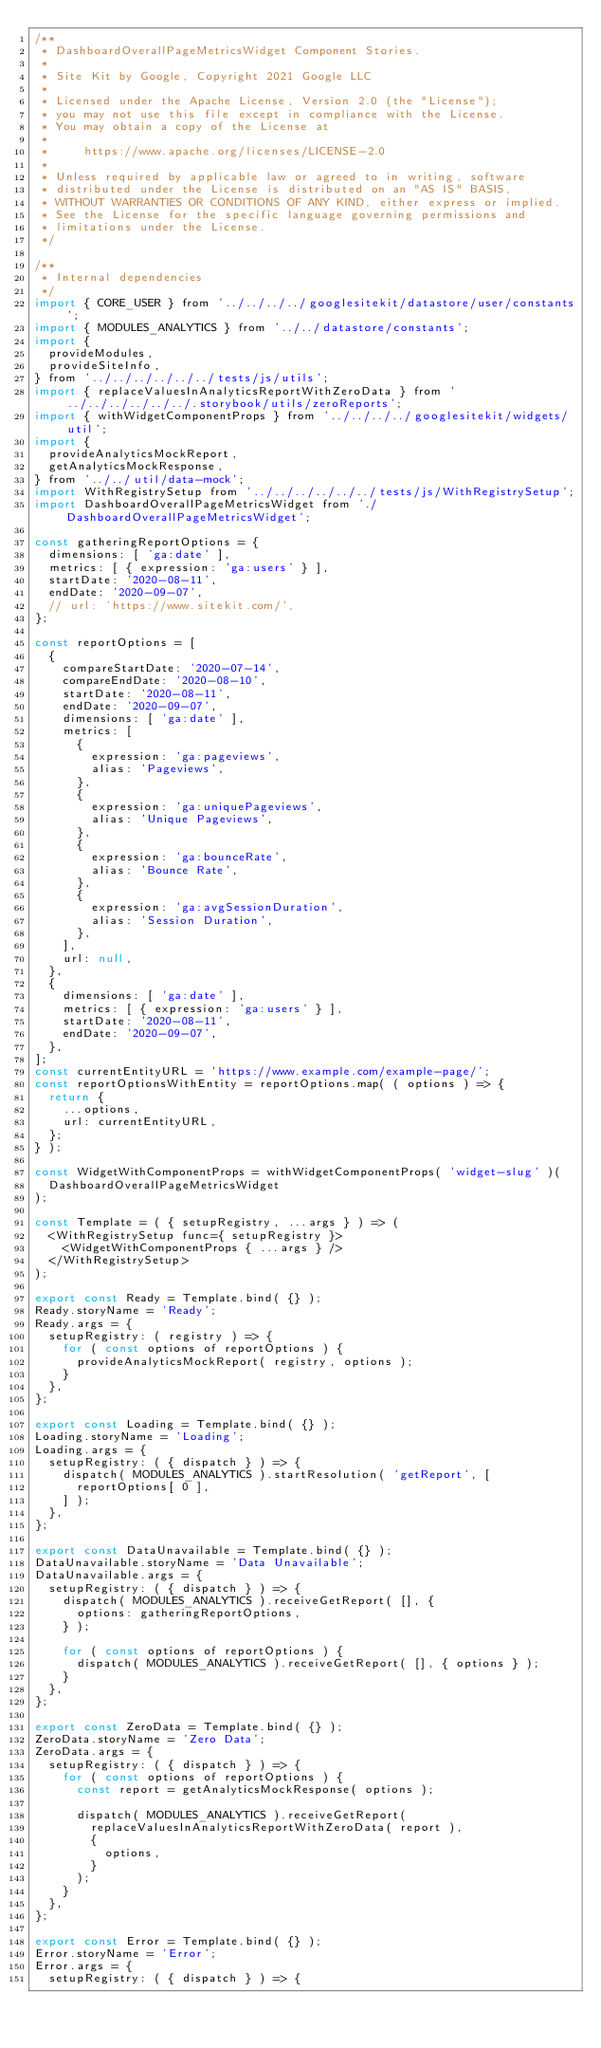Convert code to text. <code><loc_0><loc_0><loc_500><loc_500><_JavaScript_>/**
 * DashboardOverallPageMetricsWidget Component Stories.
 *
 * Site Kit by Google, Copyright 2021 Google LLC
 *
 * Licensed under the Apache License, Version 2.0 (the "License");
 * you may not use this file except in compliance with the License.
 * You may obtain a copy of the License at
 *
 *     https://www.apache.org/licenses/LICENSE-2.0
 *
 * Unless required by applicable law or agreed to in writing, software
 * distributed under the License is distributed on an "AS IS" BASIS,
 * WITHOUT WARRANTIES OR CONDITIONS OF ANY KIND, either express or implied.
 * See the License for the specific language governing permissions and
 * limitations under the License.
 */

/**
 * Internal dependencies
 */
import { CORE_USER } from '../../../../googlesitekit/datastore/user/constants';
import { MODULES_ANALYTICS } from '../../datastore/constants';
import {
	provideModules,
	provideSiteInfo,
} from '../../../../../../tests/js/utils';
import { replaceValuesInAnalyticsReportWithZeroData } from '../../../../../../.storybook/utils/zeroReports';
import { withWidgetComponentProps } from '../../../../googlesitekit/widgets/util';
import {
	provideAnalyticsMockReport,
	getAnalyticsMockResponse,
} from '../../util/data-mock';
import WithRegistrySetup from '../../../../../../tests/js/WithRegistrySetup';
import DashboardOverallPageMetricsWidget from './DashboardOverallPageMetricsWidget';

const gatheringReportOptions = {
	dimensions: [ 'ga:date' ],
	metrics: [ { expression: 'ga:users' } ],
	startDate: '2020-08-11',
	endDate: '2020-09-07',
	// url: 'https://www.sitekit.com/',
};

const reportOptions = [
	{
		compareStartDate: '2020-07-14',
		compareEndDate: '2020-08-10',
		startDate: '2020-08-11',
		endDate: '2020-09-07',
		dimensions: [ 'ga:date' ],
		metrics: [
			{
				expression: 'ga:pageviews',
				alias: 'Pageviews',
			},
			{
				expression: 'ga:uniquePageviews',
				alias: 'Unique Pageviews',
			},
			{
				expression: 'ga:bounceRate',
				alias: 'Bounce Rate',
			},
			{
				expression: 'ga:avgSessionDuration',
				alias: 'Session Duration',
			},
		],
		url: null,
	},
	{
		dimensions: [ 'ga:date' ],
		metrics: [ { expression: 'ga:users' } ],
		startDate: '2020-08-11',
		endDate: '2020-09-07',
	},
];
const currentEntityURL = 'https://www.example.com/example-page/';
const reportOptionsWithEntity = reportOptions.map( ( options ) => {
	return {
		...options,
		url: currentEntityURL,
	};
} );

const WidgetWithComponentProps = withWidgetComponentProps( 'widget-slug' )(
	DashboardOverallPageMetricsWidget
);

const Template = ( { setupRegistry, ...args } ) => (
	<WithRegistrySetup func={ setupRegistry }>
		<WidgetWithComponentProps { ...args } />
	</WithRegistrySetup>
);

export const Ready = Template.bind( {} );
Ready.storyName = 'Ready';
Ready.args = {
	setupRegistry: ( registry ) => {
		for ( const options of reportOptions ) {
			provideAnalyticsMockReport( registry, options );
		}
	},
};

export const Loading = Template.bind( {} );
Loading.storyName = 'Loading';
Loading.args = {
	setupRegistry: ( { dispatch } ) => {
		dispatch( MODULES_ANALYTICS ).startResolution( 'getReport', [
			reportOptions[ 0 ],
		] );
	},
};

export const DataUnavailable = Template.bind( {} );
DataUnavailable.storyName = 'Data Unavailable';
DataUnavailable.args = {
	setupRegistry: ( { dispatch } ) => {
		dispatch( MODULES_ANALYTICS ).receiveGetReport( [], {
			options: gatheringReportOptions,
		} );

		for ( const options of reportOptions ) {
			dispatch( MODULES_ANALYTICS ).receiveGetReport( [], { options } );
		}
	},
};

export const ZeroData = Template.bind( {} );
ZeroData.storyName = 'Zero Data';
ZeroData.args = {
	setupRegistry: ( { dispatch } ) => {
		for ( const options of reportOptions ) {
			const report = getAnalyticsMockResponse( options );

			dispatch( MODULES_ANALYTICS ).receiveGetReport(
				replaceValuesInAnalyticsReportWithZeroData( report ),
				{
					options,
				}
			);
		}
	},
};

export const Error = Template.bind( {} );
Error.storyName = 'Error';
Error.args = {
	setupRegistry: ( { dispatch } ) => {</code> 